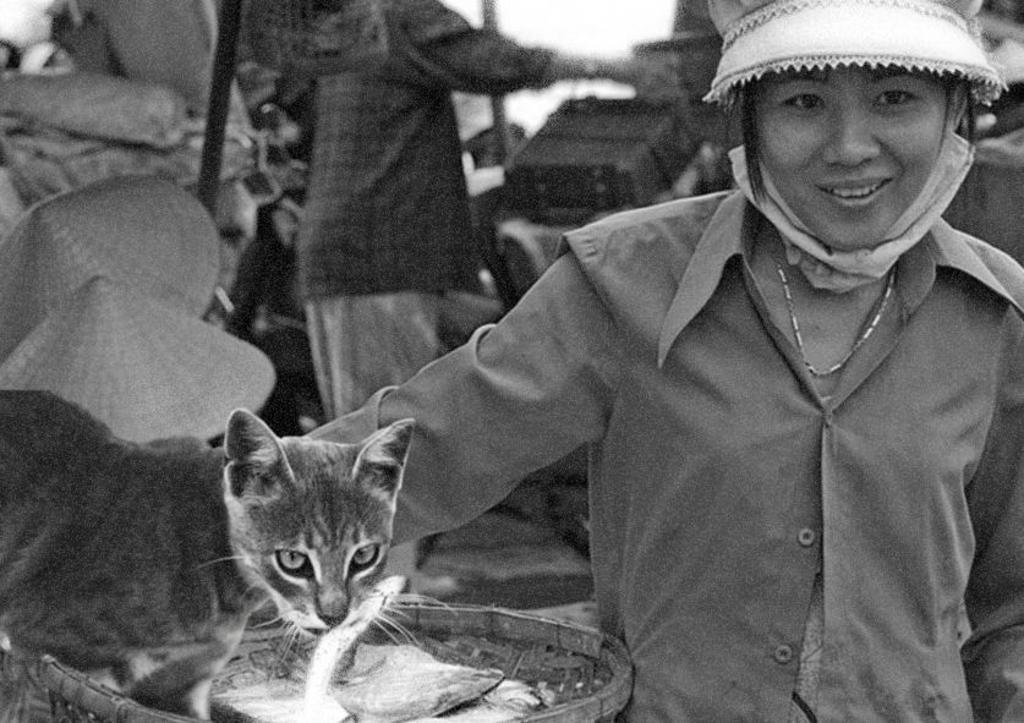How would you summarize this image in a sentence or two? This is a black and white image. In the foreground there is a cat standing on an object. On the right there is a person wearing shirt and smiling. In the background we can see a person standing and there are some objects. 